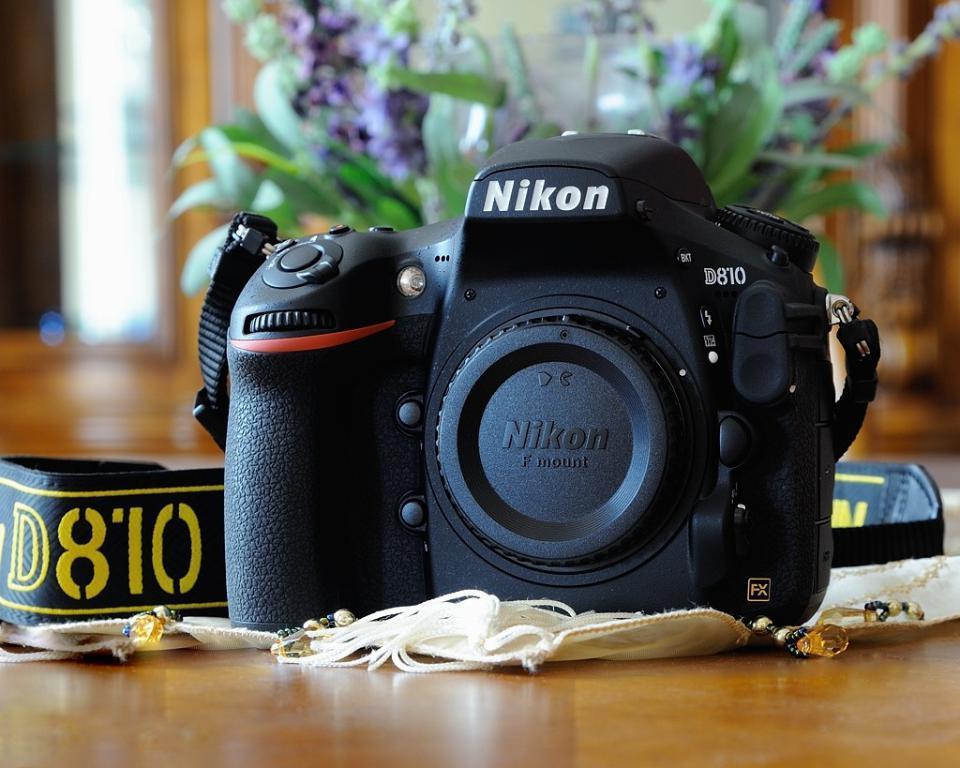Can you describe this image briefly? In this image we can see black color Nikon camera which is on the surface and in the background of the image we can see flower vase. 